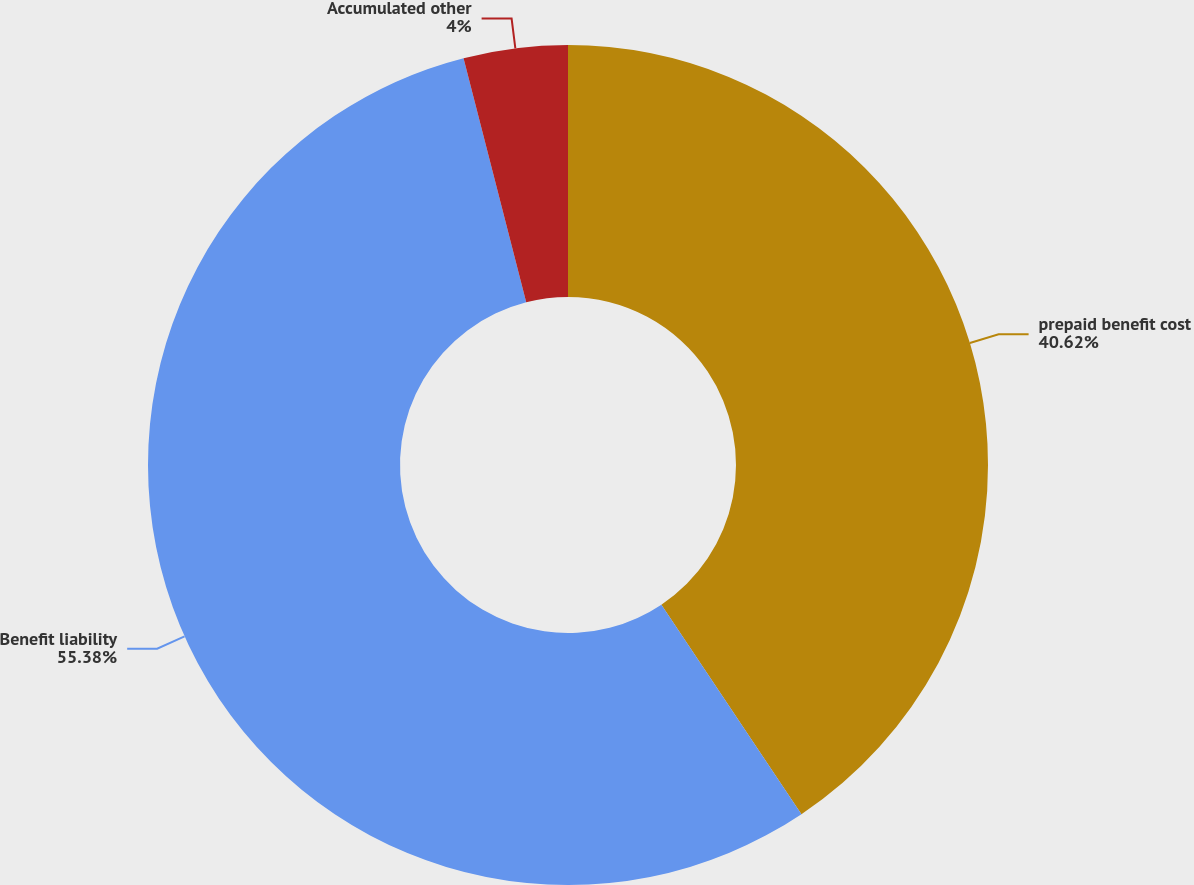<chart> <loc_0><loc_0><loc_500><loc_500><pie_chart><fcel>prepaid benefit cost<fcel>Benefit liability<fcel>Accumulated other<nl><fcel>40.62%<fcel>55.38%<fcel>4.0%<nl></chart> 